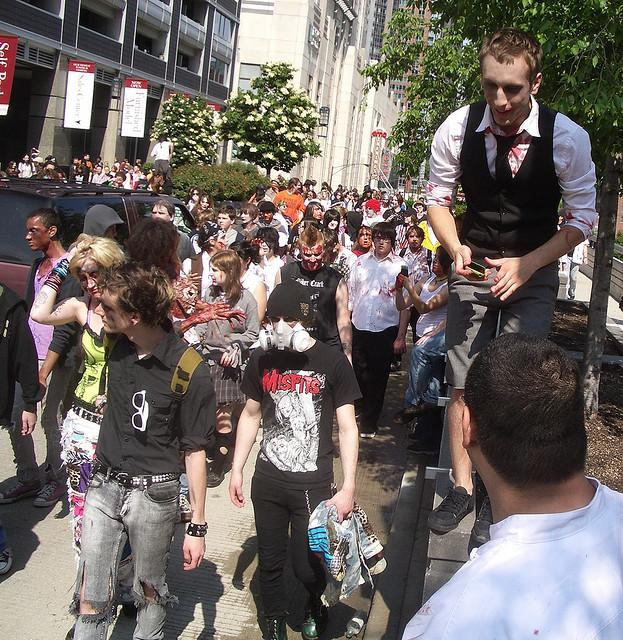The band on the shirt of the man wearing a mask belongs to what genre of music? Please explain your reasoning. punk. The man in the mask is wearing a misfits tshirt which is a famous punk band. 